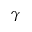Convert formula to latex. <formula><loc_0><loc_0><loc_500><loc_500>\gamma</formula> 